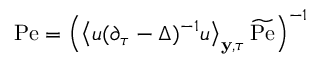<formula> <loc_0><loc_0><loc_500><loc_500>P e = \left ( \left \langle u ( \partial _ { \tau } - \Delta ) ^ { - 1 } u \right \rangle _ { y , \tau } \widetilde { P e } \right ) ^ { - 1 }</formula> 